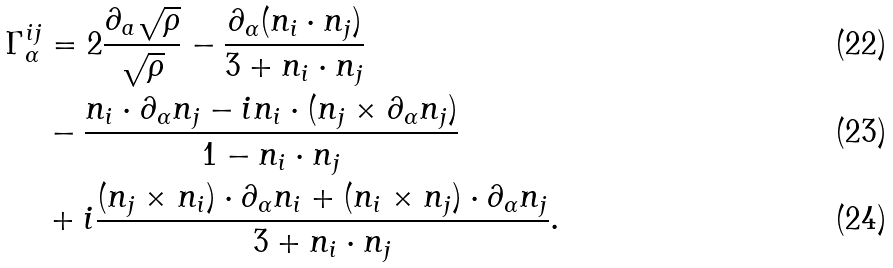Convert formula to latex. <formula><loc_0><loc_0><loc_500><loc_500>\Gamma ^ { i j } _ { \alpha } & = 2 \frac { \partial _ { a } \sqrt { \rho } } { \sqrt { \rho } } - \frac { \partial _ { \alpha } ( { n } _ { i } \cdot { n } _ { j } ) } { 3 + { n } _ { i } \cdot { n } _ { j } } \\ \quad & - \frac { { n } _ { i } \cdot \partial _ { \alpha } { n } _ { j } - i { n } _ { i } \cdot ( { n } _ { j } \times \partial _ { \alpha } { n _ { j } } ) } { 1 - { n } _ { i } \cdot { n } _ { j } } \\ \quad & + i \frac { ( { n } _ { j } \times { n } _ { i } ) \cdot \partial _ { \alpha } { n } _ { i } + ( { n } _ { i } \times { n } _ { j } ) \cdot \partial _ { \alpha } { n } _ { j } } { 3 + { n } _ { i } \cdot { n } _ { j } } .</formula> 